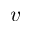Convert formula to latex. <formula><loc_0><loc_0><loc_500><loc_500>v</formula> 